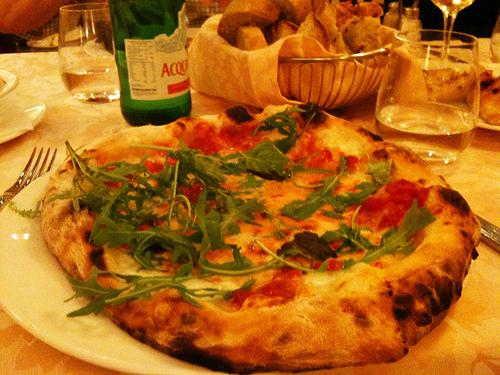What is the primary food item on the table, and what are some of its visible toppings? The primary food item is a vegetable pizza on a white plate, with green lettuce, melted cheese, and sliced red tomatoes as visible toppings. For the multi-choice VQA task, identify the correct statement among the following: A) The pizza has no toppings. B) The fork is blue. C) The bread is in a basket. D) The tablecloth is plain. C) The bread is in a basket. Where is the fork placed on the table, and what is its color? The fork is placed next to the plate and is gray metal. What are the distinct kinds of garnish visible on the pizza? Green lettuce, basil, and red sauce are some distinct garnishes visible on the pizza. What objects are near the pizza, and what are their positions relative to the pizza? A glass of water is to the right of the pizza, and a green bottle is to the left. A silver fork is placed next to the plate on which the pizza is served. Describe the table setting, including the tablecloth and the objects' arrangement. The table is set with a pizza on a white plate and a glass of water, a green bottle, and a gray metal fork nearby. The tablecloth has a floral print, and there's a basket with bread in the center of the table. Mention the location and description of the bread and the basket. The bread is in a gray metal basket located in the center of the table. In the context of a product advertisement task, describe the pizza's appearance and taste based on the image. Indulge in our mouthwatering vegetable pizza, topped with fresh green lettuce, juicy red tomatoes, and melted cheese. Savor the delightful crunch of the perfectly toasted crust with every bite. What are the unique features of the glass next to the pizza and the green bottle? The glass next to the pizza is a clear round short glass, while the green bottle has a white label on it. 